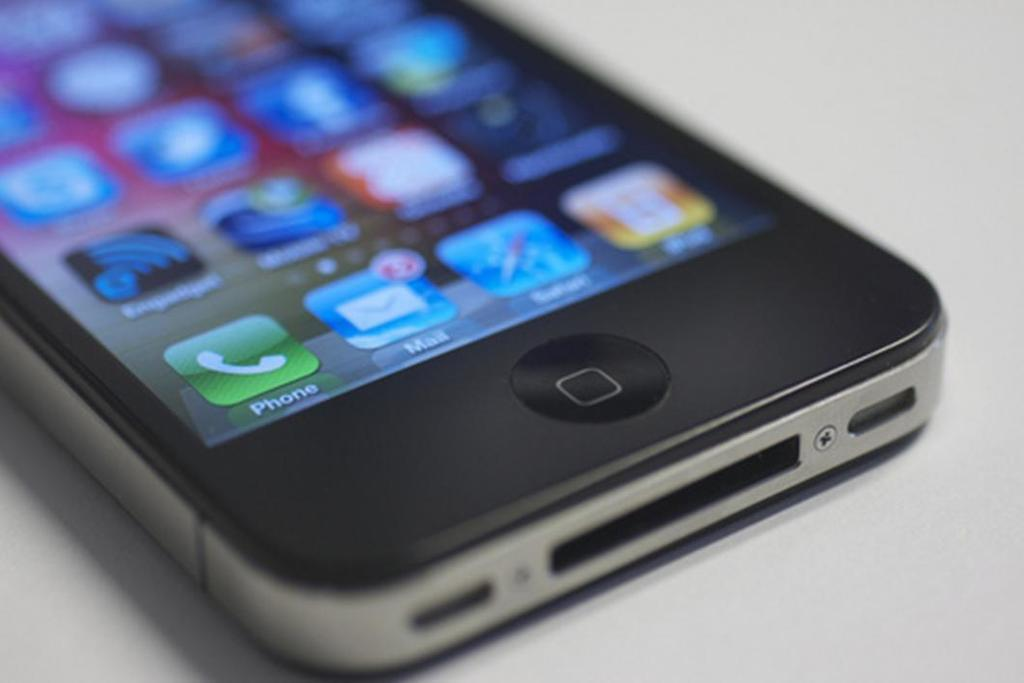<image>
Create a compact narrative representing the image presented. an icon on a phone that says mail 